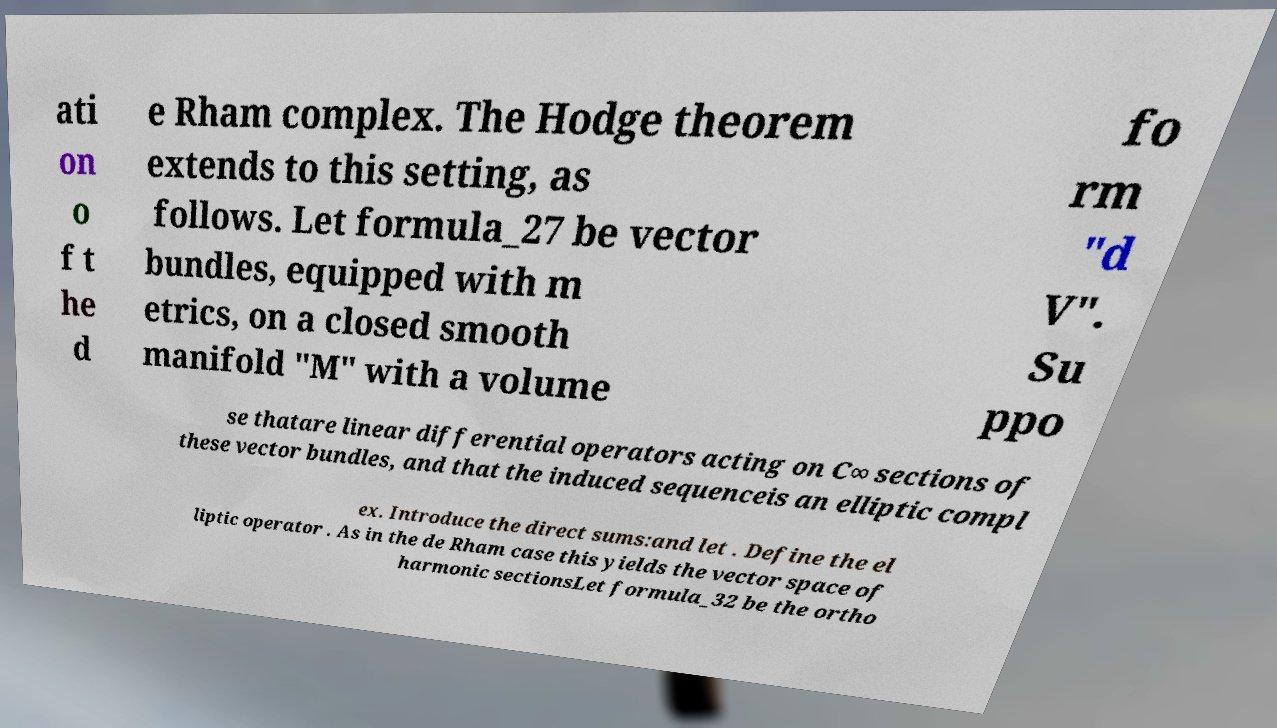Could you extract and type out the text from this image? ati on o f t he d e Rham complex. The Hodge theorem extends to this setting, as follows. Let formula_27 be vector bundles, equipped with m etrics, on a closed smooth manifold "M" with a volume fo rm "d V". Su ppo se thatare linear differential operators acting on C∞ sections of these vector bundles, and that the induced sequenceis an elliptic compl ex. Introduce the direct sums:and let . Define the el liptic operator . As in the de Rham case this yields the vector space of harmonic sectionsLet formula_32 be the ortho 